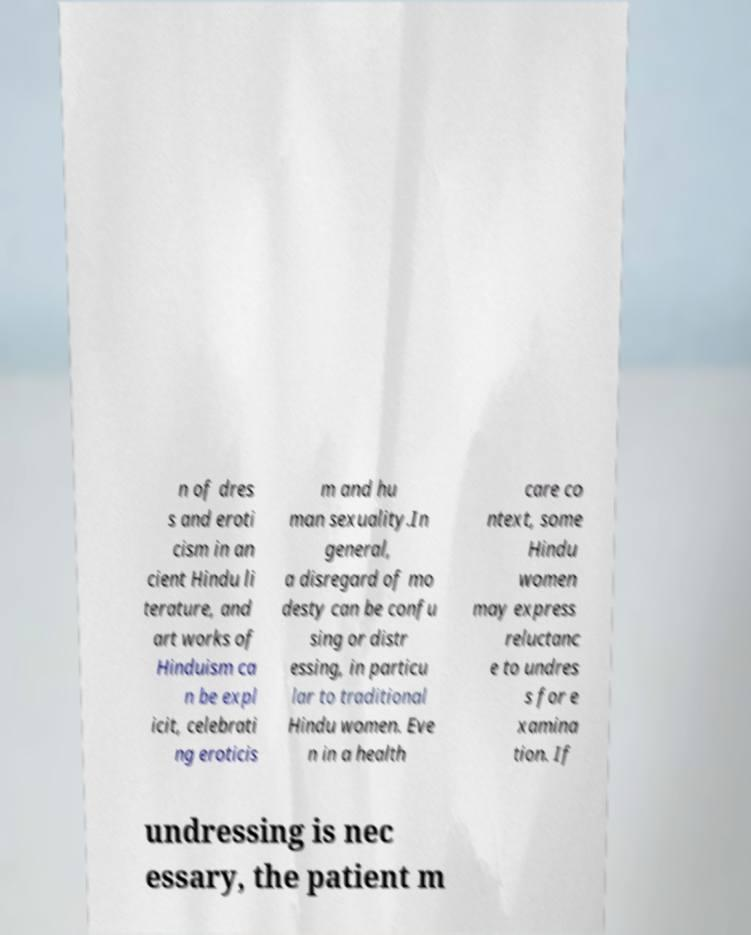Can you read and provide the text displayed in the image?This photo seems to have some interesting text. Can you extract and type it out for me? n of dres s and eroti cism in an cient Hindu li terature, and art works of Hinduism ca n be expl icit, celebrati ng eroticis m and hu man sexuality.In general, a disregard of mo desty can be confu sing or distr essing, in particu lar to traditional Hindu women. Eve n in a health care co ntext, some Hindu women may express reluctanc e to undres s for e xamina tion. If undressing is nec essary, the patient m 